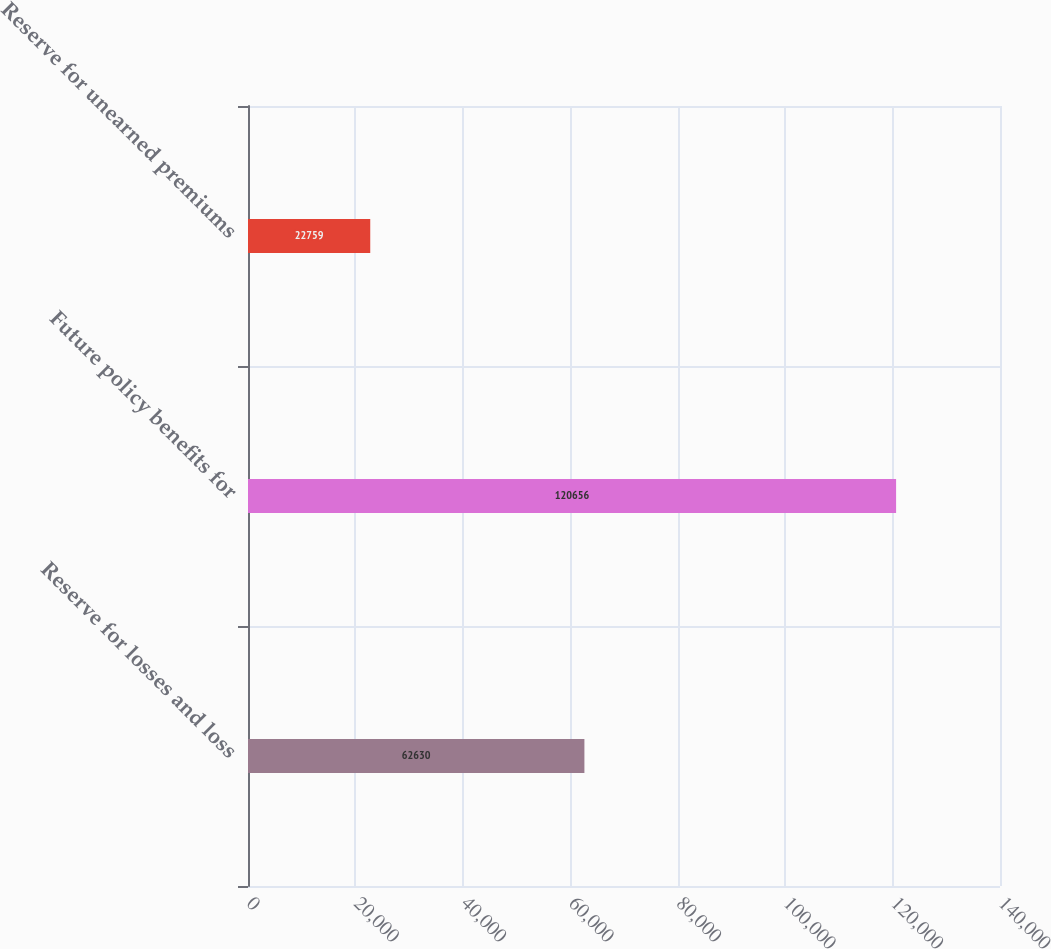<chart> <loc_0><loc_0><loc_500><loc_500><bar_chart><fcel>Reserve for losses and loss<fcel>Future policy benefits for<fcel>Reserve for unearned premiums<nl><fcel>62630<fcel>120656<fcel>22759<nl></chart> 